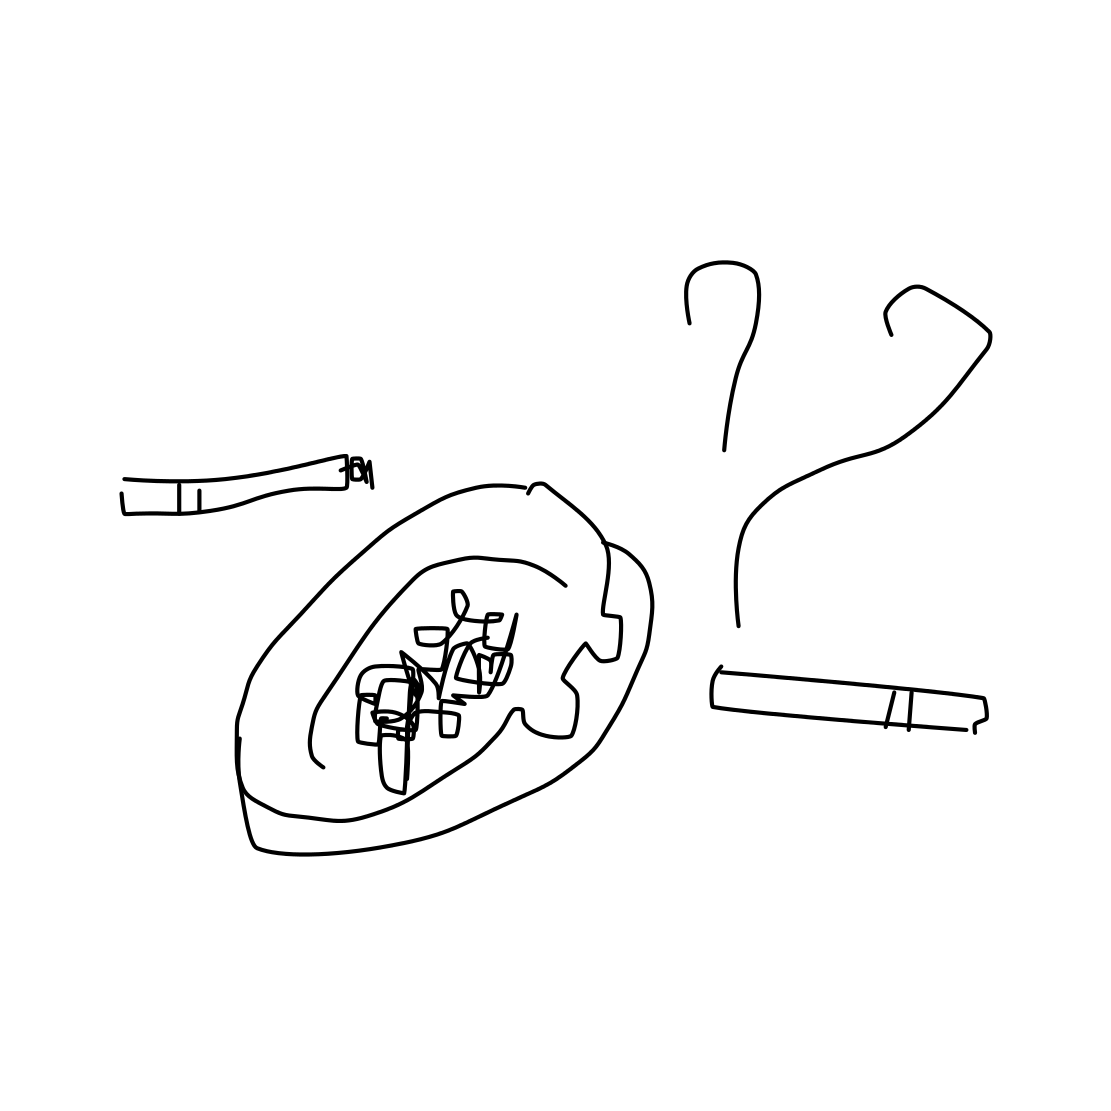In the scene, is an ashtray in it? Yes 